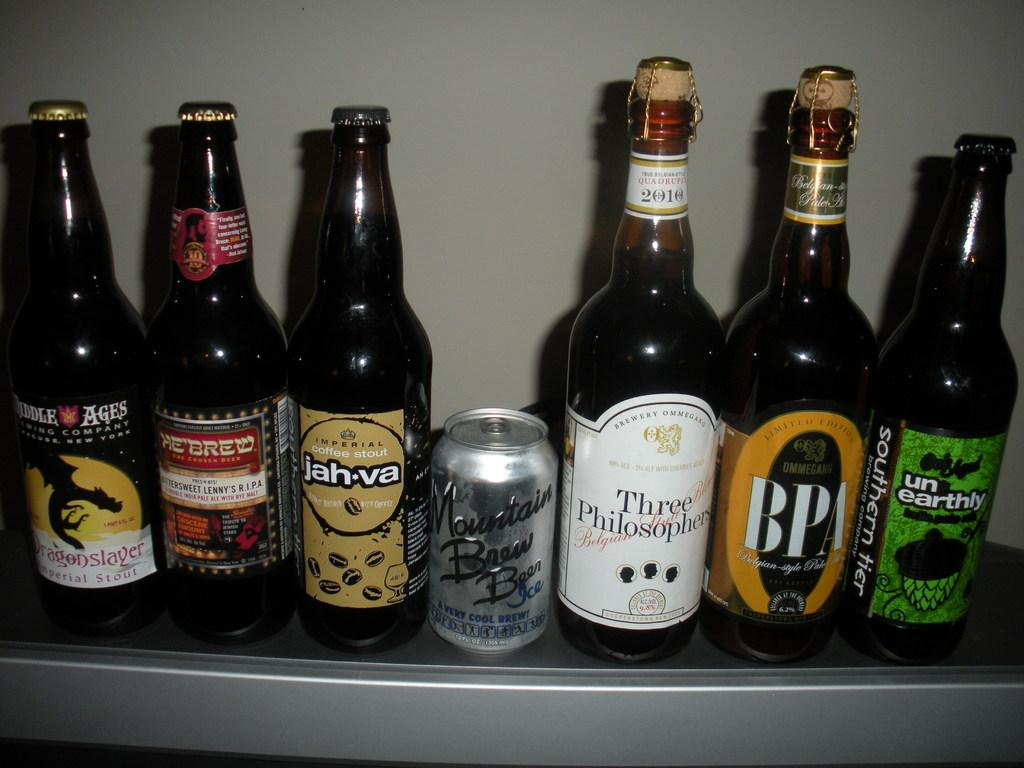<image>
Give a short and clear explanation of the subsequent image. Bottles of Unearthly and Three Philosophers beer on a shelf. 